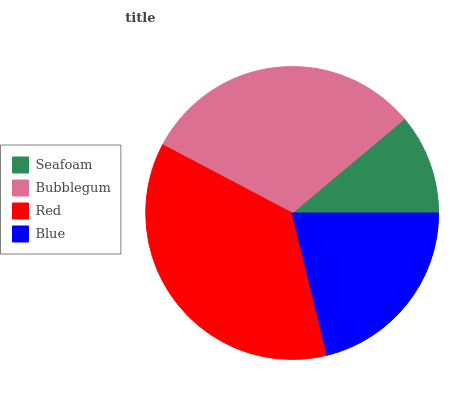Is Seafoam the minimum?
Answer yes or no. Yes. Is Red the maximum?
Answer yes or no. Yes. Is Bubblegum the minimum?
Answer yes or no. No. Is Bubblegum the maximum?
Answer yes or no. No. Is Bubblegum greater than Seafoam?
Answer yes or no. Yes. Is Seafoam less than Bubblegum?
Answer yes or no. Yes. Is Seafoam greater than Bubblegum?
Answer yes or no. No. Is Bubblegum less than Seafoam?
Answer yes or no. No. Is Bubblegum the high median?
Answer yes or no. Yes. Is Blue the low median?
Answer yes or no. Yes. Is Seafoam the high median?
Answer yes or no. No. Is Bubblegum the low median?
Answer yes or no. No. 